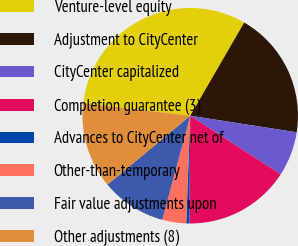Convert chart. <chart><loc_0><loc_0><loc_500><loc_500><pie_chart><fcel>Venture-level equity<fcel>Adjustment to CityCenter<fcel>CityCenter capitalized<fcel>Completion guarantee (3)<fcel>Advances to CityCenter net of<fcel>Other-than-temporary<fcel>Fair value adjustments upon<fcel>Other adjustments (8)<nl><fcel>31.51%<fcel>19.1%<fcel>6.68%<fcel>15.99%<fcel>0.47%<fcel>3.58%<fcel>9.78%<fcel>12.89%<nl></chart> 